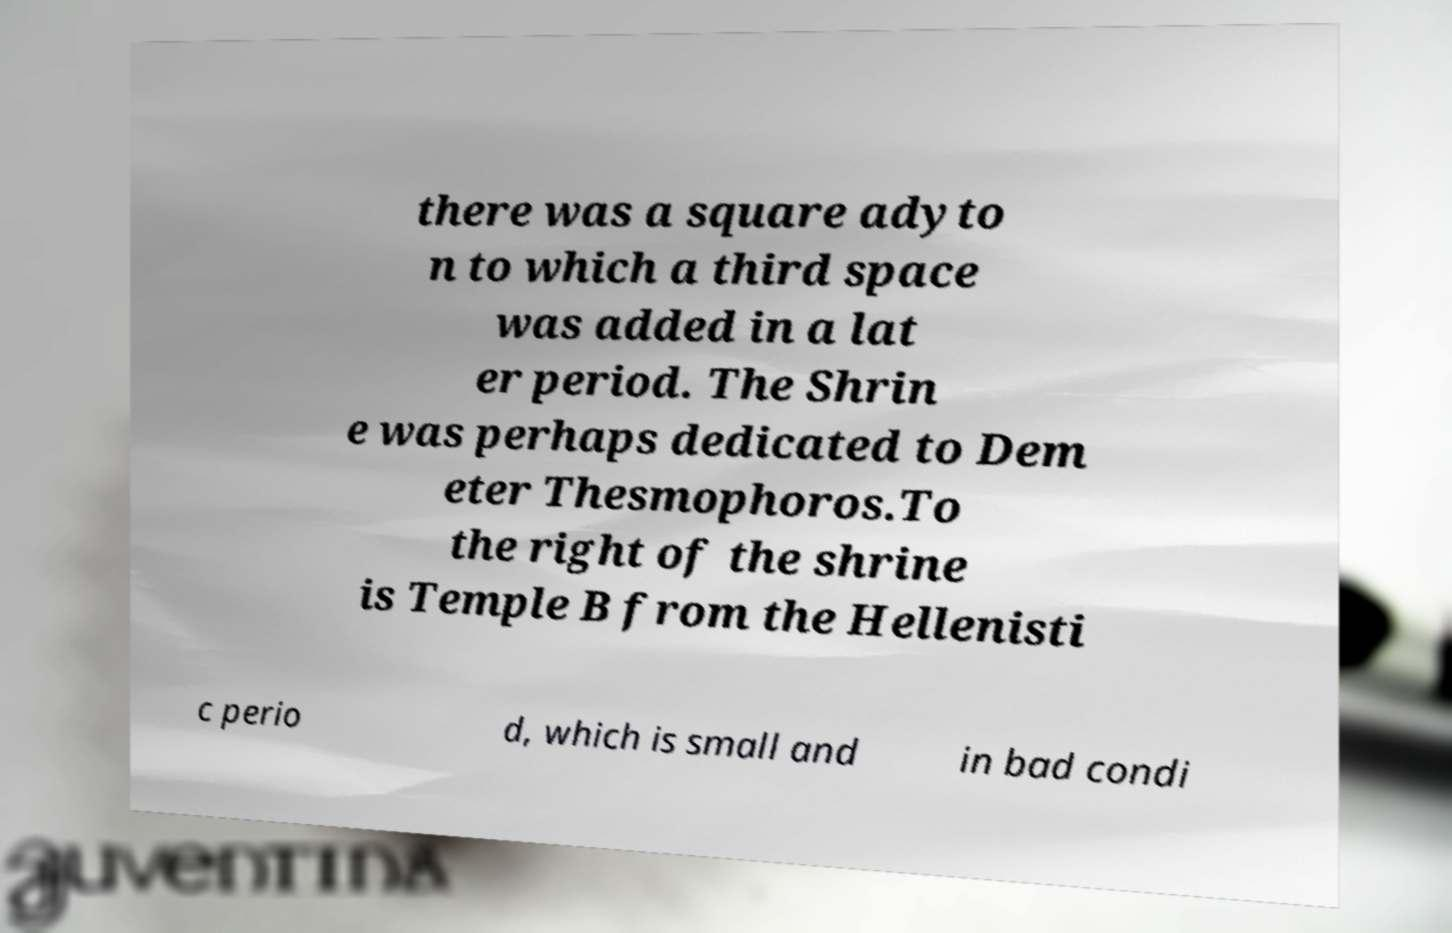Could you extract and type out the text from this image? there was a square adyto n to which a third space was added in a lat er period. The Shrin e was perhaps dedicated to Dem eter Thesmophoros.To the right of the shrine is Temple B from the Hellenisti c perio d, which is small and in bad condi 